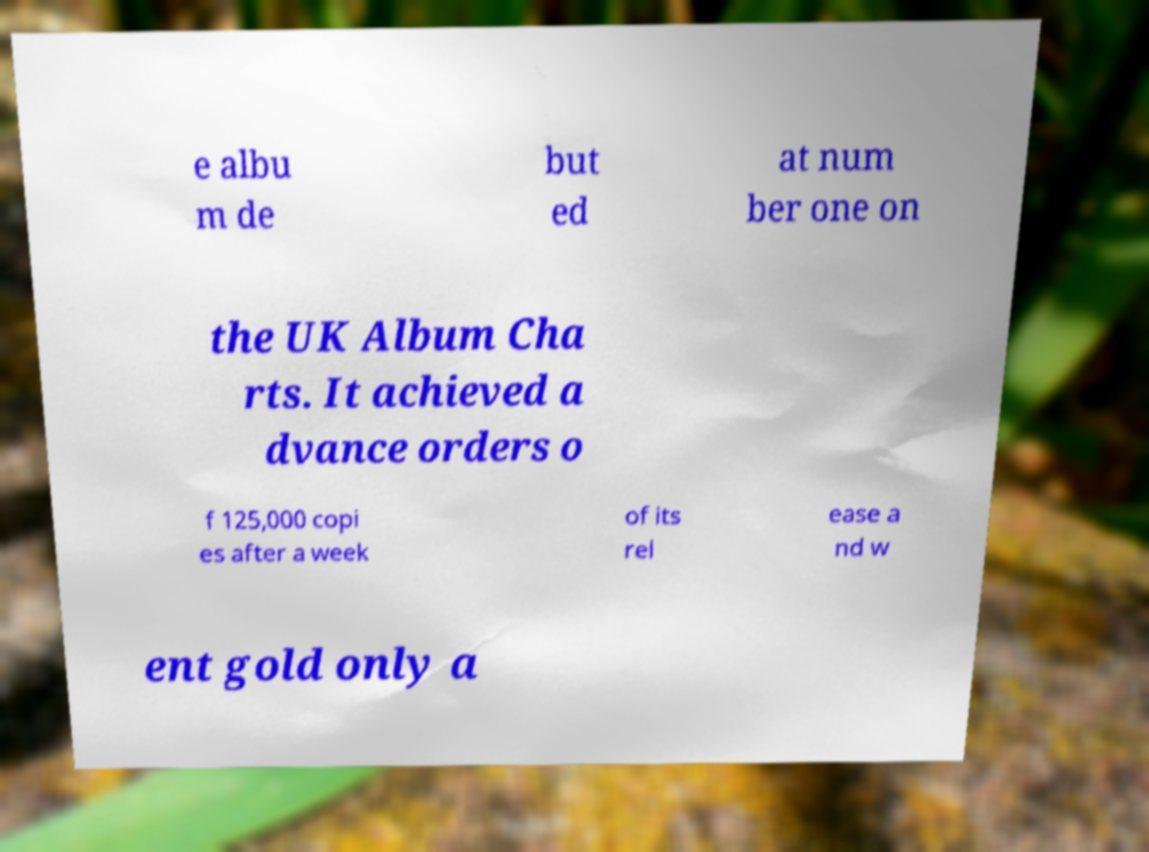Please identify and transcribe the text found in this image. e albu m de but ed at num ber one on the UK Album Cha rts. It achieved a dvance orders o f 125,000 copi es after a week of its rel ease a nd w ent gold only a 